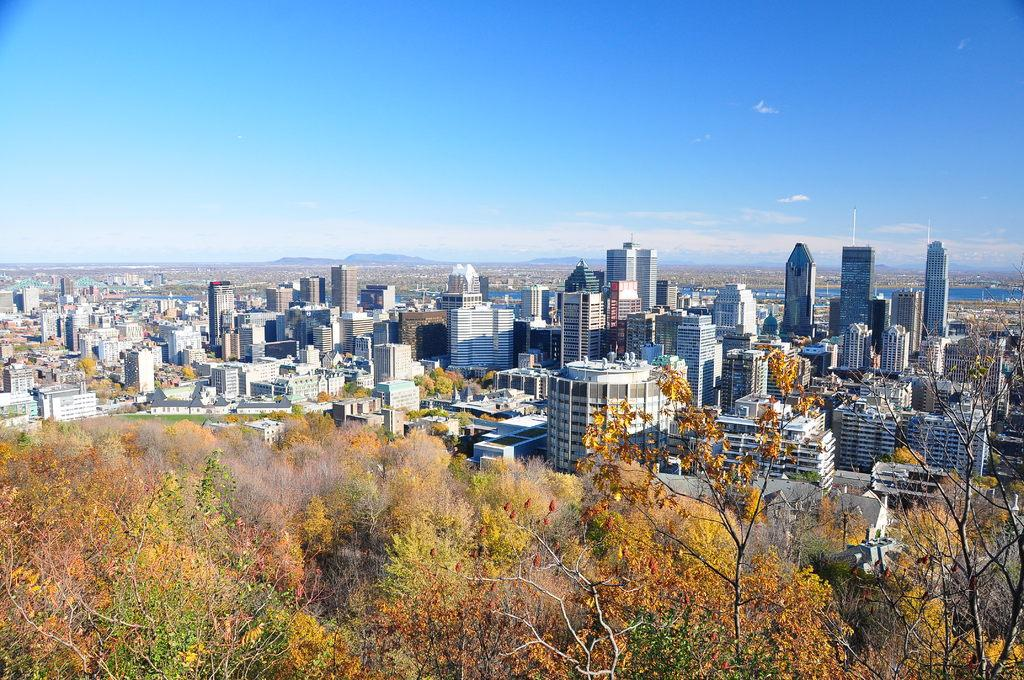What type of natural elements can be seen in the image? There are trees in the image. What type of man-made structures are present in the image? There are buildings in the image. What can be seen in the distance in the image? There is water, hills, and clouds visible in the background of the image. What type of mint is growing on the buildings in the image? There is no mint growing on the buildings in the image; the image only features trees, buildings, and natural elements in the background. 